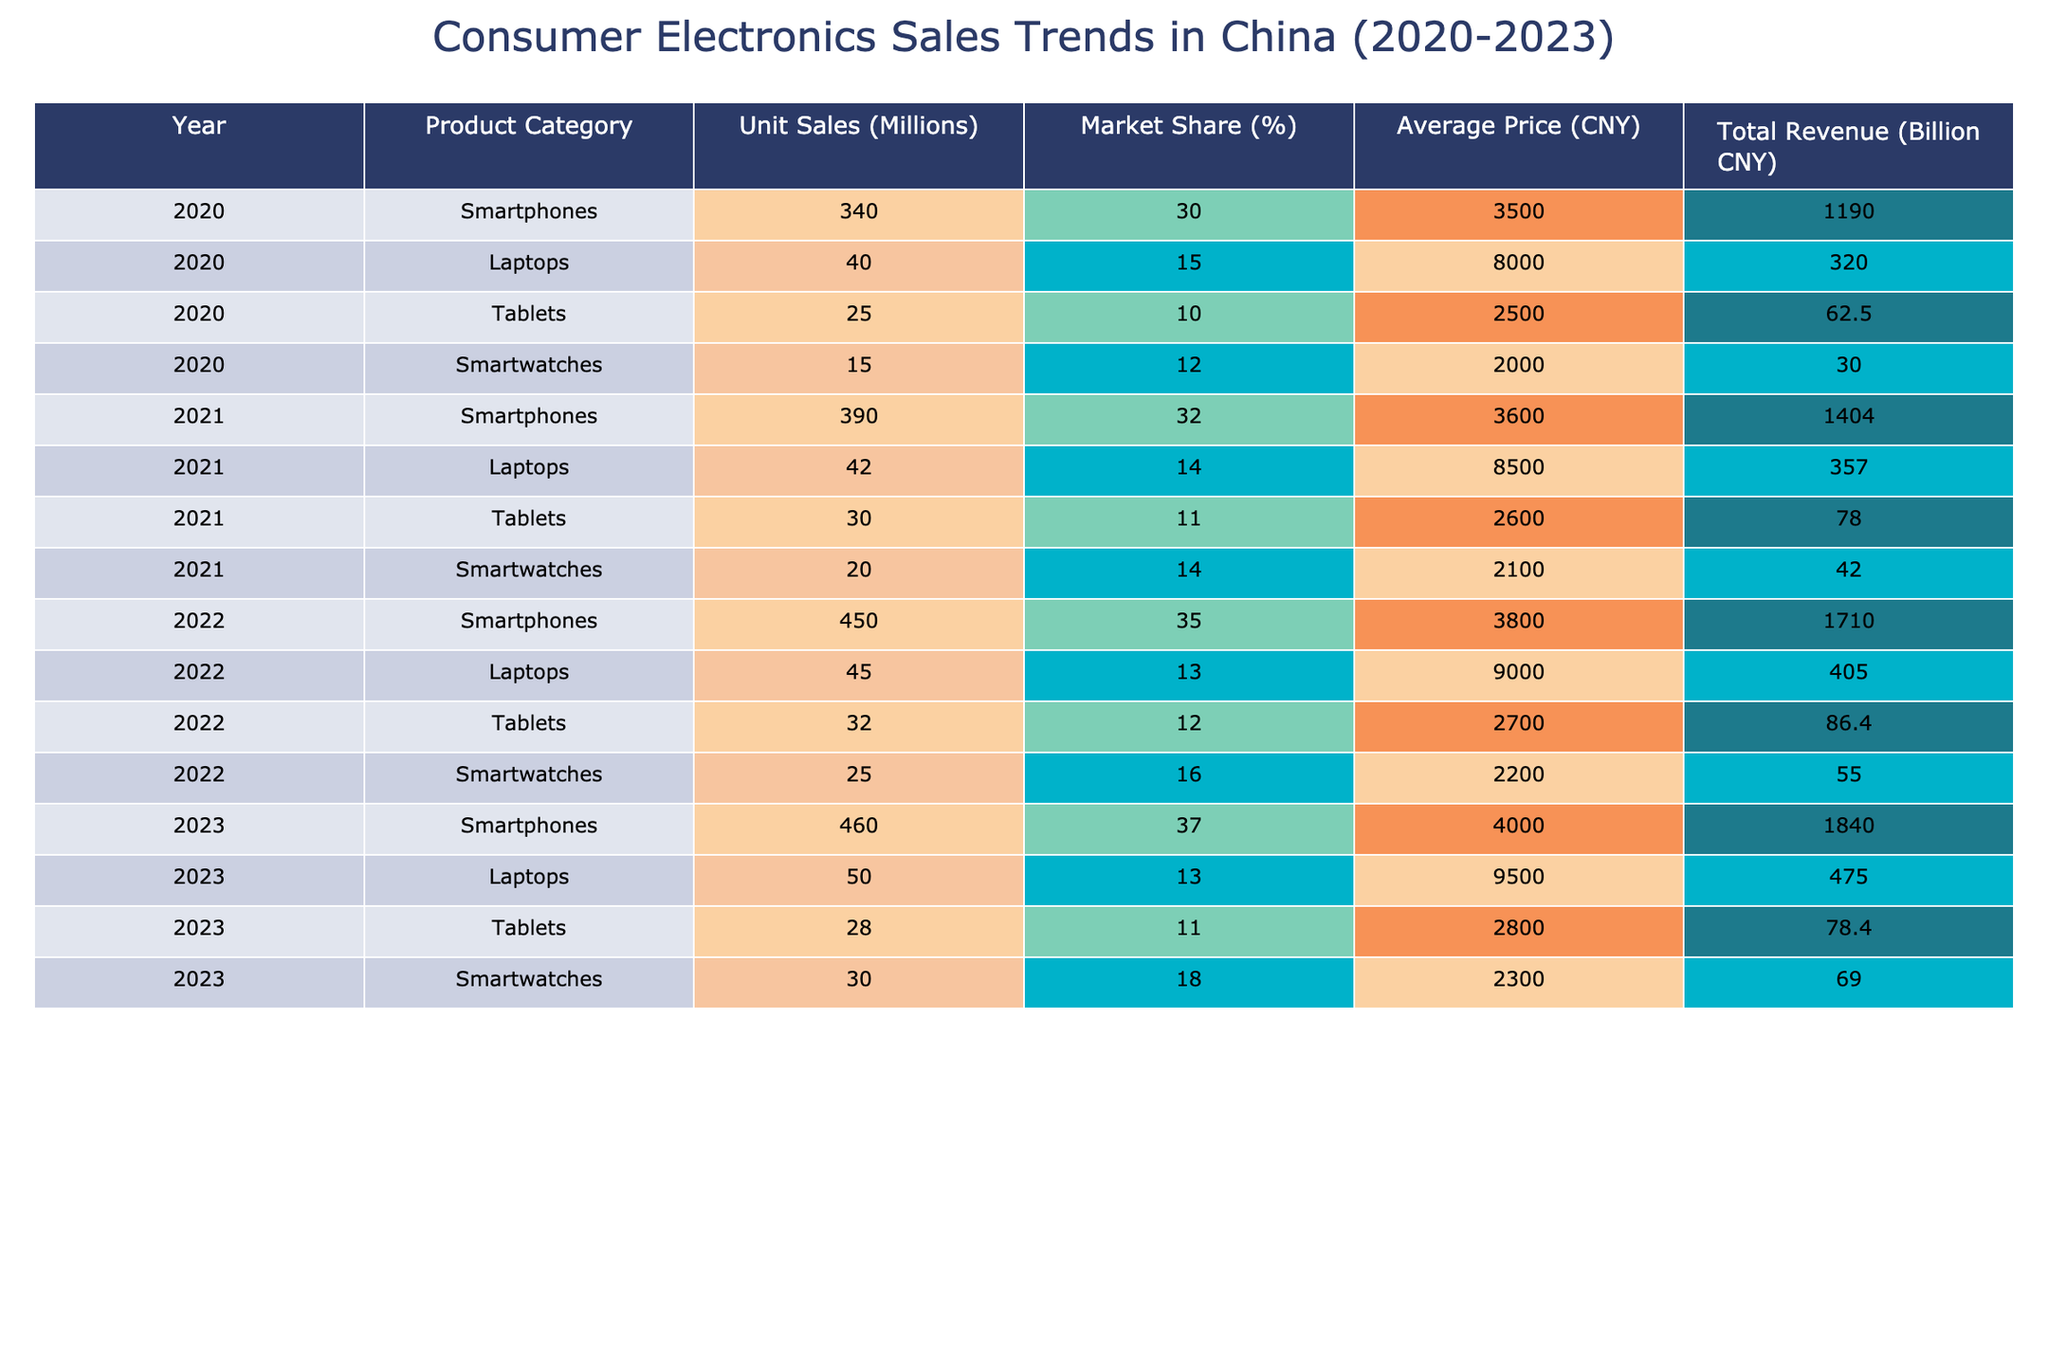What was the total revenue from smartphone sales in 2022? In the table, the total revenue from smartphone sales in 2022 is listed as 1710 billion CNY.
Answer: 1710 billion CNY Which product category had the highest market share in 2023? In 2023, smartphones had a market share of 37%, which is the highest when compared to the other categories (laptops at 13%, tablets at 11%, and smartwatches at 18%).
Answer: Smartphones What was the average price of laptops in 2021 and 2022? For laptops, the average price in 2021 was 8500 CNY and in 2022 was 9000 CNY. To find the average, we sum the prices (8500 + 9000) = 17500 and divide by 2, giving us 17500 / 2 = 8750 CNY.
Answer: 8750 CNY Did the unit sales of tablets increase every year from 2020 to 2023? Looking at the unit sales of tablets: in 2020 it was 25 million, in 2021 it was 30 million, in 2022 it was 32 million, and in 2023 it dropped to 28 million. Therefore, the unit sales of tablets did not increase every year.
Answer: No What was the percentage increase in smartphone unit sales from 2021 to 2022? Smartphone unit sales increased from 390 million in 2021 to 450 million in 2022. To find the percentage increase, we compute the difference (450 - 390 = 60), then divide by the original value (60 / 390 ≈ 0.1538) and multiply by 100 to get ≈ 15.38%.
Answer: Approximately 15.38% Which product category generated the least revenue in 2020? In 2020, the revenues were: smartphones 1190 billion CNY, laptops 320 billion CNY, tablets 62.5 billion CNY, and smartwatches 30 billion CNY. Thus, the least revenue is from smartwatches at 30 billion CNY.
Answer: Smartwatches What is the total revenue generated by laptops from 2020 to 2023? The revenues for laptops over the years are: 320 billion CNY (2020) + 357 billion CNY (2021) + 405 billion CNY (2022) + 475 billion CNY (2023) = 1557 billion CNY.
Answer: 1557 billion CNY Did the average price of smartwatches increase from 2020 to 2023? The average price for smartwatches increased as follows: 2000 CNY in 2020, 2100 CNY in 2021, 2200 CNY in 2022, and 2300 CNY in 2023. Since each year shows an increase, the average price of smartwatches did indeed increase.
Answer: Yes What was the market share of tablets in 2022, and how does it compare to 2021? Tablets had a market share of 12% in 2022, which is slightly higher than 11% in 2021, indicating a marginal increase of 1%.
Answer: 12% 